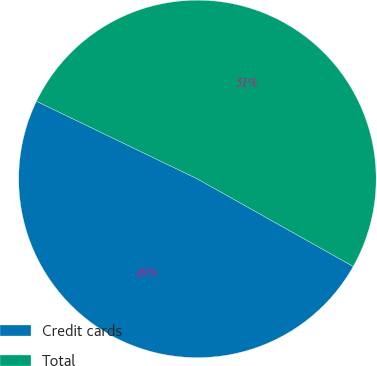<chart> <loc_0><loc_0><loc_500><loc_500><pie_chart><fcel>Credit cards<fcel>Total<nl><fcel>49.01%<fcel>50.99%<nl></chart> 